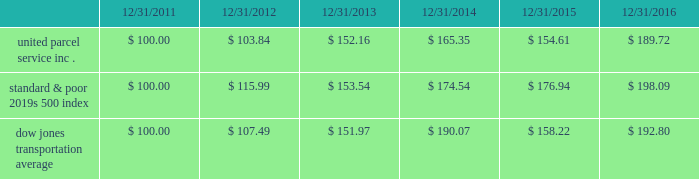Shareowner return performance graph the following performance graph and related information shall not be deemed 201csoliciting material 201d or to be 201cfiled 201d with the sec , nor shall such information be incorporated by reference into any future filing under the securities act of 1933 or securities exchange act of 1934 , each as amended , except to the extent that the company specifically incorporates such information by reference into such filing .
The following graph shows a five year comparison of cumulative total shareowners 2019 returns for our class b common stock , the standard & poor 2019s 500 index and the dow jones transportation average .
The comparison of the total cumulative return on investment , which is the change in the quarterly stock price plus reinvested dividends for each of the quarterly periods , assumes that $ 100 was invested on december 31 , 2011 in the standard & poor 2019s 500 index , the dow jones transportation average and our class b common stock. .

What was the percentage cumulative total shareowners return for united parcel service inc . for the five years ended 12/31/2016? 
Computations: ((189.72 - 100) / 100)
Answer: 0.8972. 